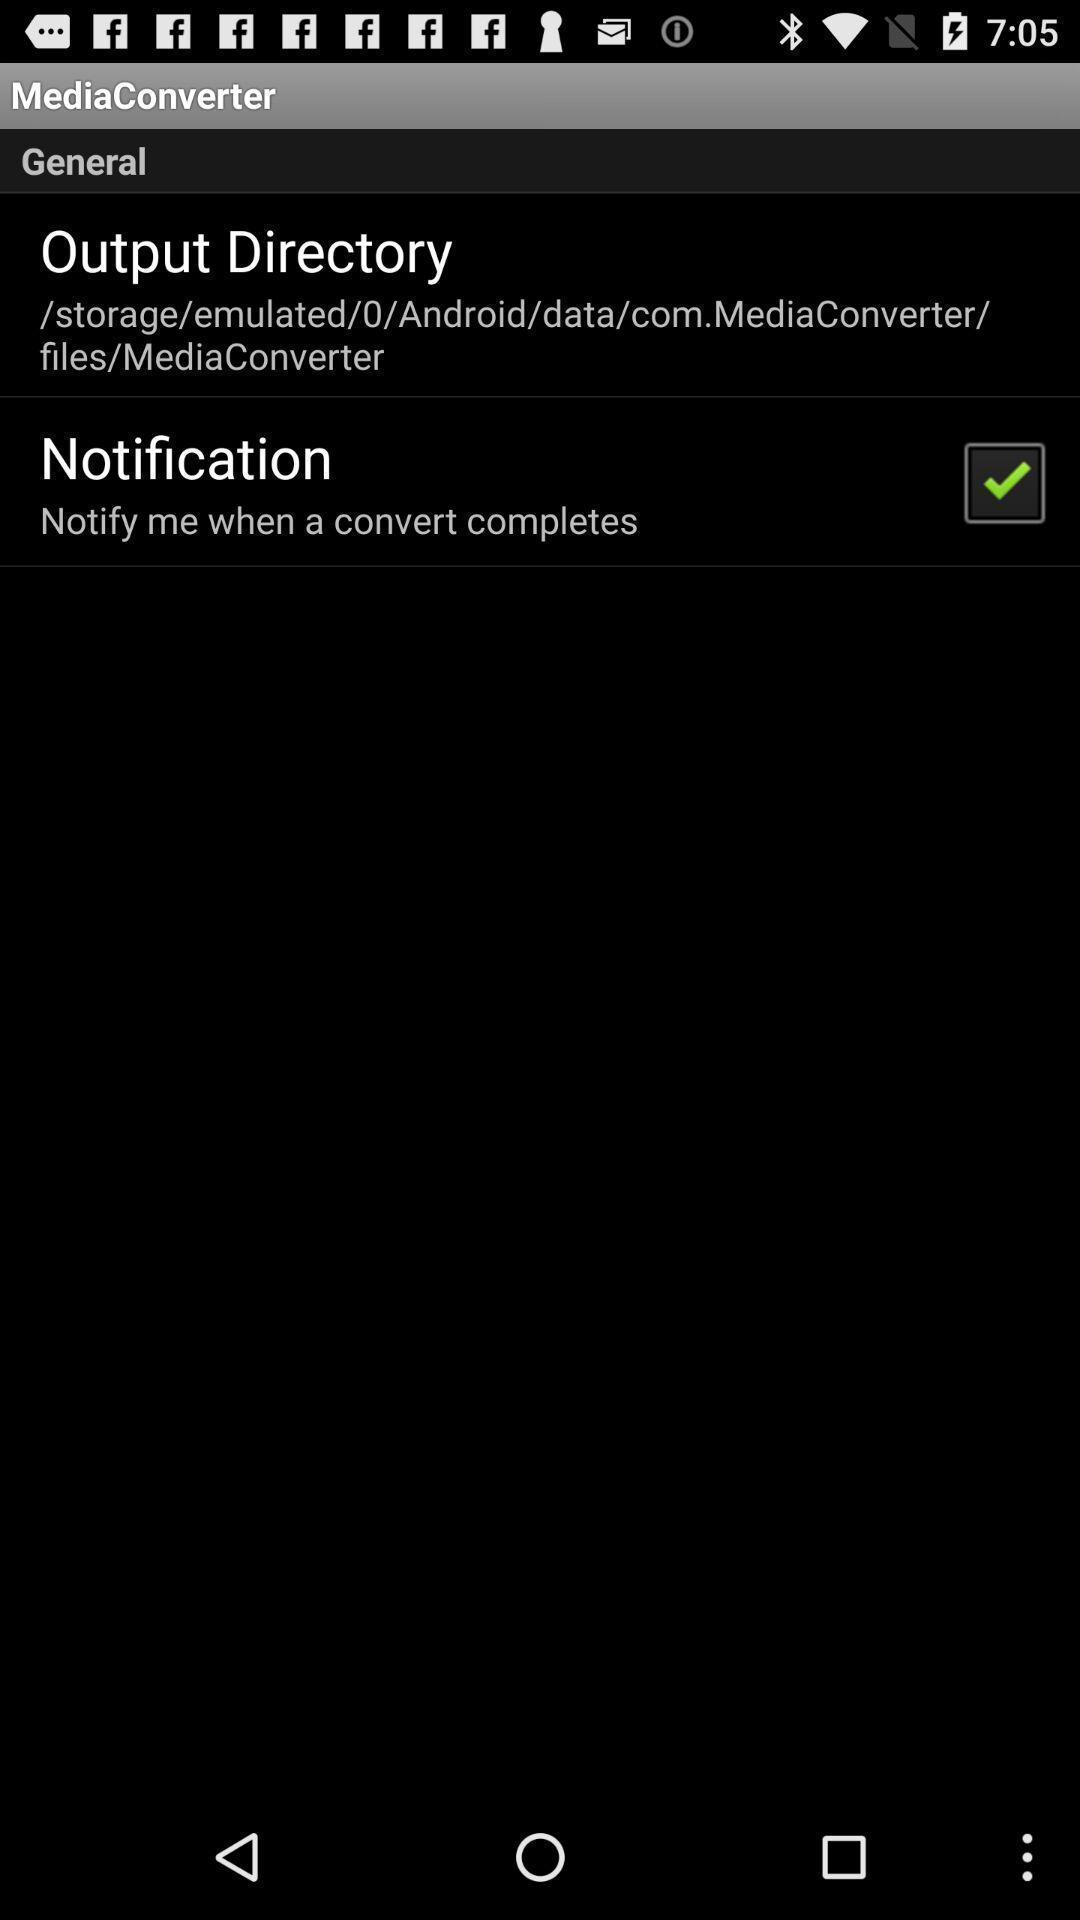Explain what's happening in this screen capture. Page showing different options under media converter. 